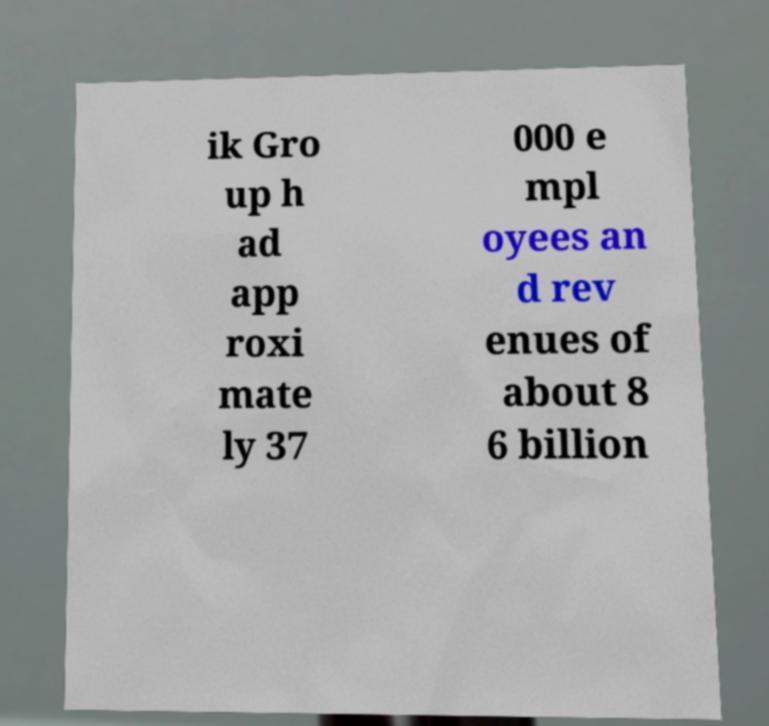For documentation purposes, I need the text within this image transcribed. Could you provide that? ik Gro up h ad app roxi mate ly 37 000 e mpl oyees an d rev enues of about 8 6 billion 